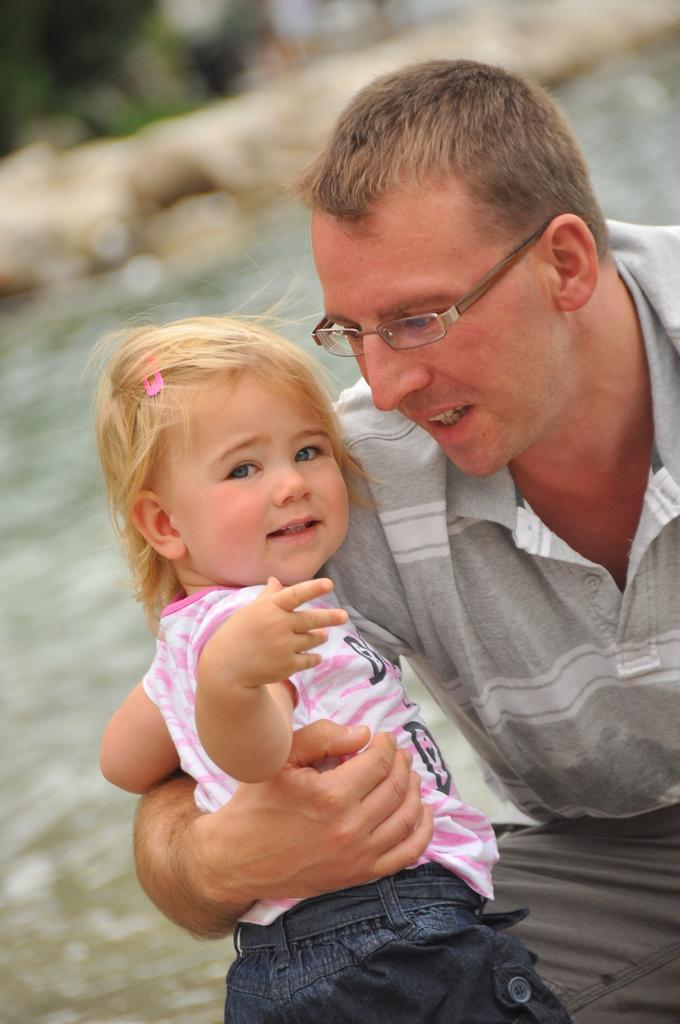What is the main subject of the image? The main subject of the image is a man. What is the man doing in the image? The man is holding a girl in the image. Can you describe the man's appearance? The man is wearing spectacles, a t-shirt, and pants. What can be observed about the background of the image? The background of the image is blurred. What type of education does the man have in the image? There is no information about the man's education in the image. How much fuel is required for the man to hold the girl in the image? There is no mention of fuel or any vehicle in the image, so this question cannot be answered. 